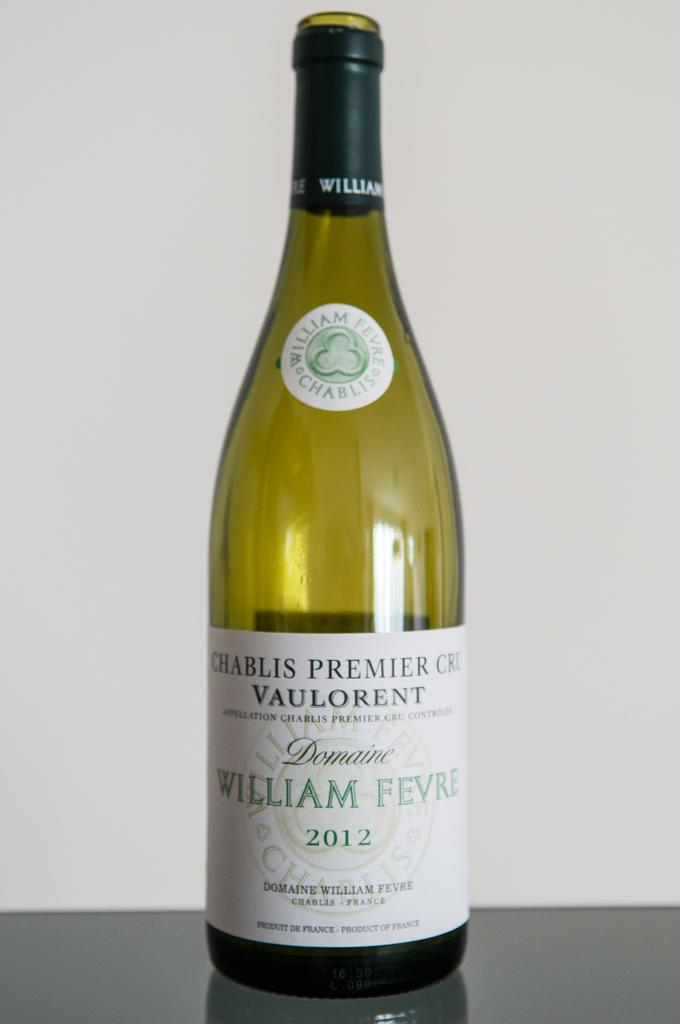<image>
Summarize the visual content of the image. A bottle of chablis is labeled with the year 2012. 